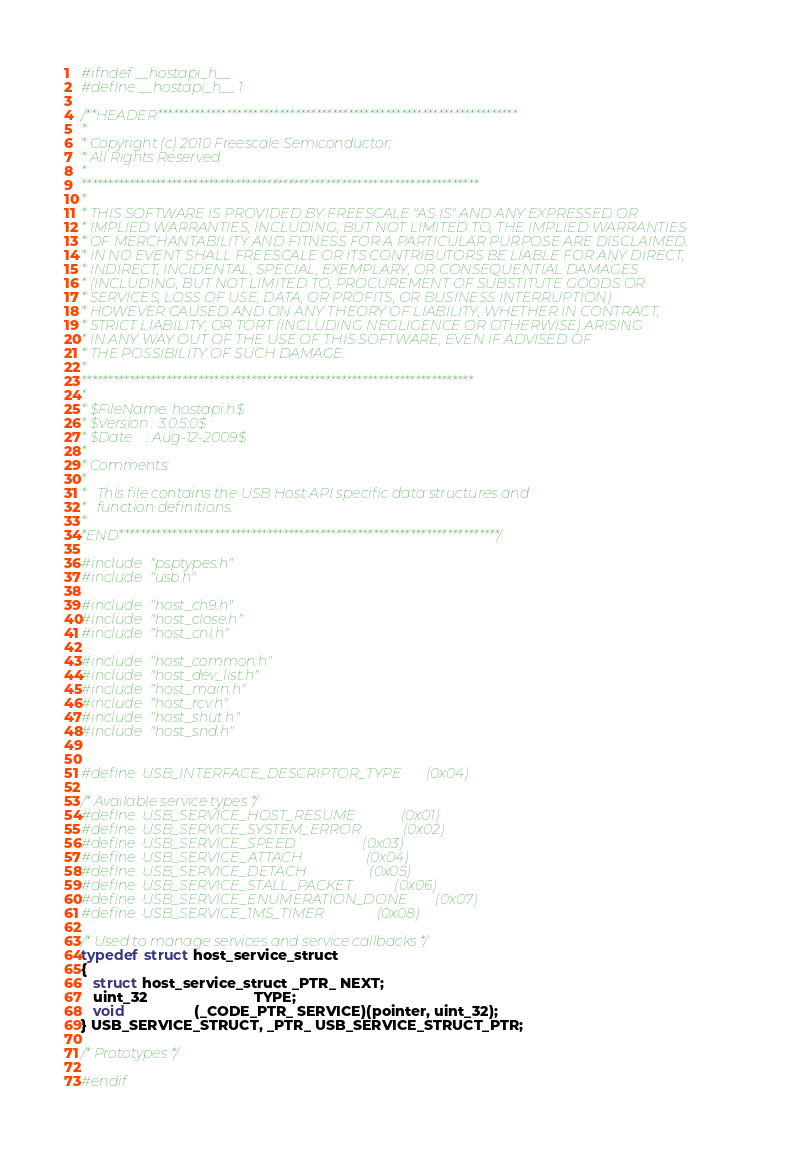<code> <loc_0><loc_0><loc_500><loc_500><_C_>#ifndef __hostapi_h__
#define __hostapi_h__ 1

/**HEADER********************************************************************
* 
* Copyright (c) 2010 Freescale Semiconductor;
* All Rights Reserved
*
*************************************************************************** 
*
* THIS SOFTWARE IS PROVIDED BY FREESCALE "AS IS" AND ANY EXPRESSED OR 
* IMPLIED WARRANTIES, INCLUDING, BUT NOT LIMITED TO, THE IMPLIED WARRANTIES 
* OF MERCHANTABILITY AND FITNESS FOR A PARTICULAR PURPOSE ARE DISCLAIMED.  
* IN NO EVENT SHALL FREESCALE OR ITS CONTRIBUTORS BE LIABLE FOR ANY DIRECT, 
* INDIRECT, INCIDENTAL, SPECIAL, EXEMPLARY, OR CONSEQUENTIAL DAMAGES 
* (INCLUDING, BUT NOT LIMITED TO, PROCUREMENT OF SUBSTITUTE GOODS OR 
* SERVICES; LOSS OF USE, DATA, OR PROFITS; OR BUSINESS INTERRUPTION) 
* HOWEVER CAUSED AND ON ANY THEORY OF LIABILITY, WHETHER IN CONTRACT, 
* STRICT LIABILITY, OR TORT (INCLUDING NEGLIGENCE OR OTHERWISE) ARISING 
* IN ANY WAY OUT OF THE USE OF THIS SOFTWARE, EVEN IF ADVISED OF 
* THE POSSIBILITY OF SUCH DAMAGE.
*
**************************************************************************
*
* $FileName: hostapi.h$
* $Version : 3.0.5.0$
* $Date    : Aug-12-2009$
*
* Comments:
*
*   This file contains the USB Host API specific data structures and
*   function definitions.
*
*END************************************************************************/

#include "psptypes.h"
#include "usb.h"

#include "host_ch9.h"
#include "host_close.h"
#include "host_cnl.h"

#include "host_common.h"
#include "host_dev_list.h"
#include "host_main.h"
#include "host_rcv.h"
#include "host_shut.h"
#include "host_snd.h"


#define  USB_INTERFACE_DESCRIPTOR_TYPE       (0x04)

/* Available service types */
#define  USB_SERVICE_HOST_RESUME             (0x01)
#define  USB_SERVICE_SYSTEM_ERROR            (0x02)
#define  USB_SERVICE_SPEED                   (0x03)
#define  USB_SERVICE_ATTACH                  (0x04)
#define  USB_SERVICE_DETACH                  (0x05)
#define  USB_SERVICE_STALL_PACKET            (0x06)
#define  USB_SERVICE_ENUMERATION_DONE        (0x07)
#define  USB_SERVICE_1MS_TIMER               (0x08)

/* Used to manage services and service callbacks */
typedef struct host_service_struct
{
   struct host_service_struct _PTR_ NEXT;
   uint_32                          TYPE;
   void                 (_CODE_PTR_ SERVICE)(pointer, uint_32);
} USB_SERVICE_STRUCT, _PTR_ USB_SERVICE_STRUCT_PTR;

/* Prototypes */

#endif
</code> 